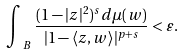<formula> <loc_0><loc_0><loc_500><loc_500>\int _ { \ B } \frac { ( 1 - | z | ^ { 2 } ) ^ { s } d \mu ( w ) } { | 1 - \langle z , w \rangle | ^ { p + s } } < \varepsilon .</formula> 